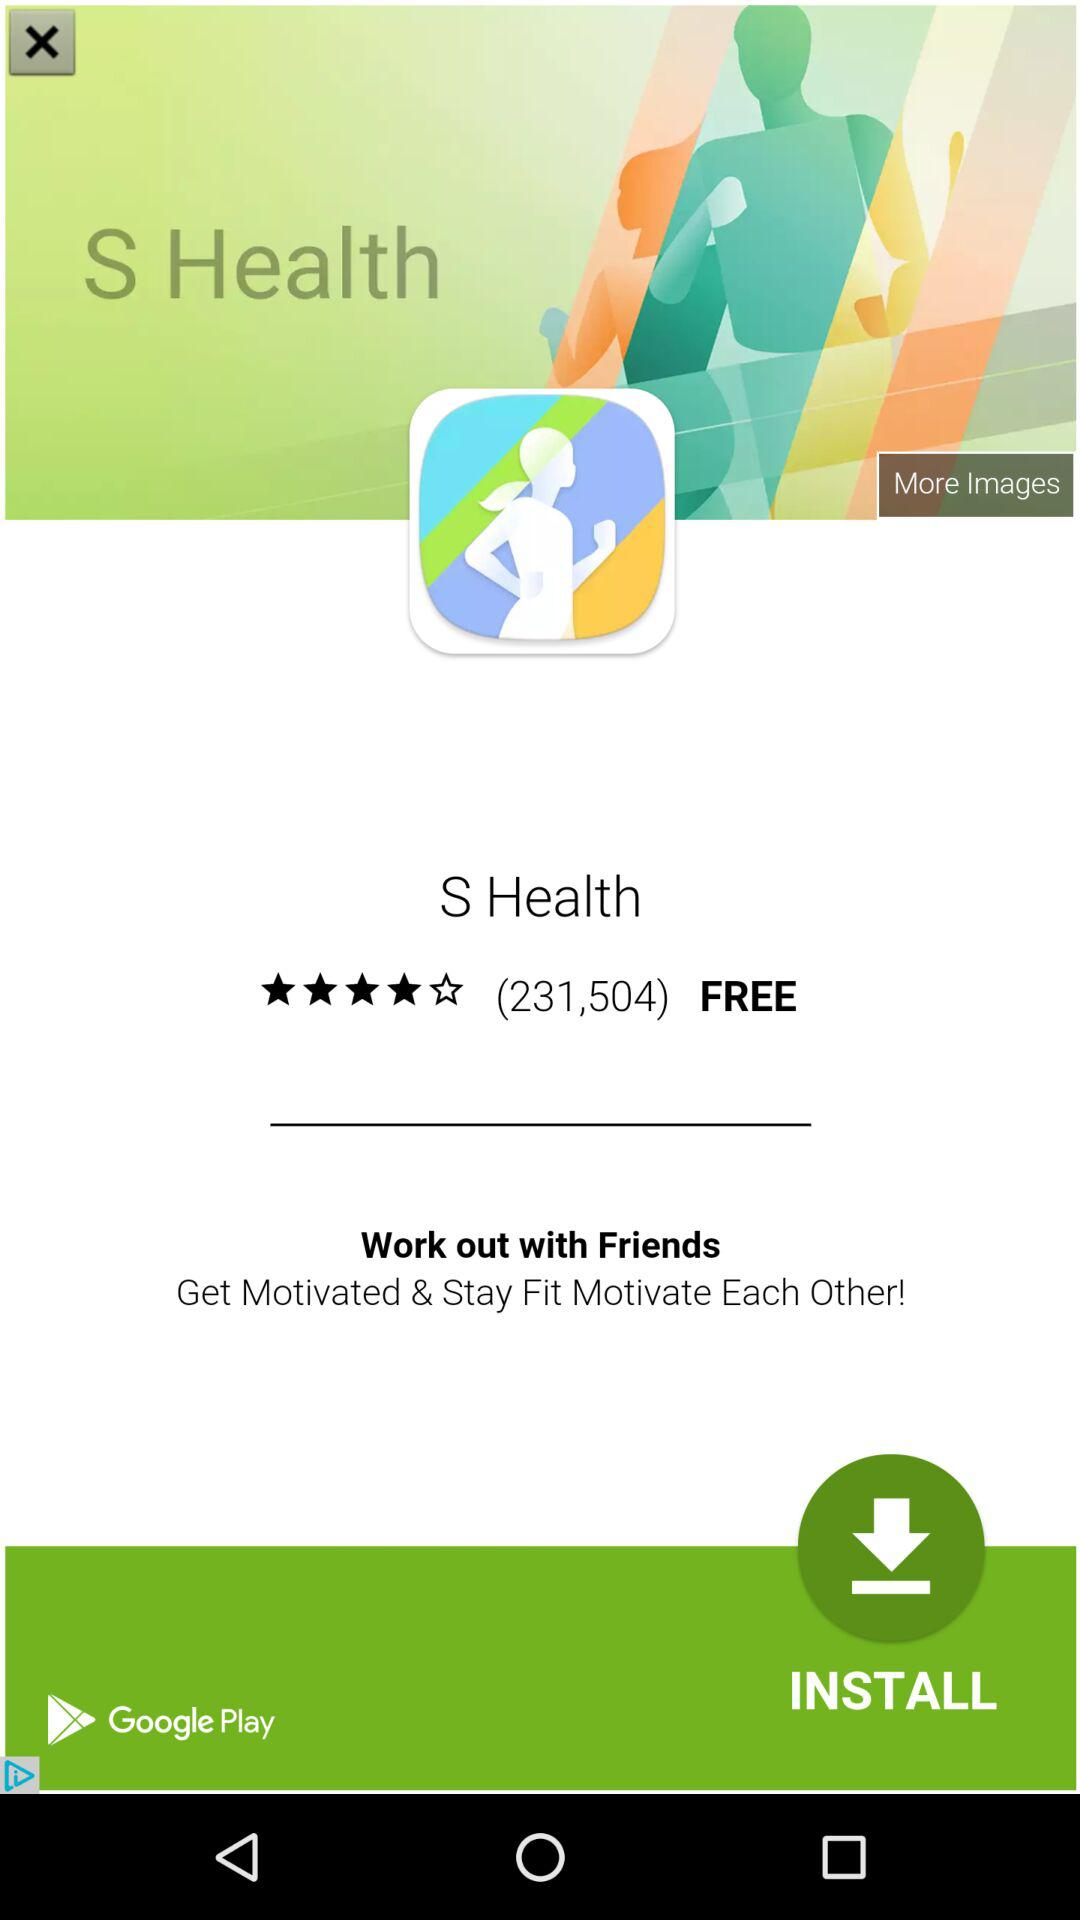How many seconds longer is the rest period than the work period?
Answer the question using a single word or phrase. 10 